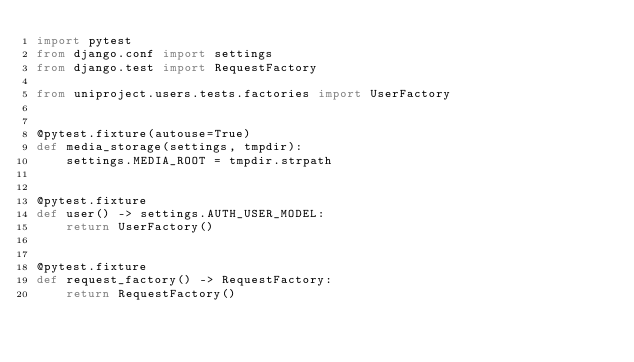<code> <loc_0><loc_0><loc_500><loc_500><_Python_>import pytest
from django.conf import settings
from django.test import RequestFactory

from uniproject.users.tests.factories import UserFactory


@pytest.fixture(autouse=True)
def media_storage(settings, tmpdir):
    settings.MEDIA_ROOT = tmpdir.strpath


@pytest.fixture
def user() -> settings.AUTH_USER_MODEL:
    return UserFactory()


@pytest.fixture
def request_factory() -> RequestFactory:
    return RequestFactory()
</code> 